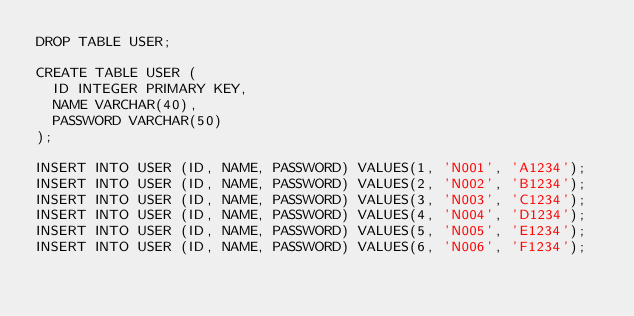Convert code to text. <code><loc_0><loc_0><loc_500><loc_500><_SQL_>DROP TABLE USER;

CREATE TABLE USER (
	ID INTEGER PRIMARY KEY,
	NAME VARCHAR(40),
	PASSWORD VARCHAR(50)
);

INSERT INTO USER (ID, NAME, PASSWORD) VALUES(1, 'N001', 'A1234');
INSERT INTO USER (ID, NAME, PASSWORD) VALUES(2, 'N002', 'B1234');
INSERT INTO USER (ID, NAME, PASSWORD) VALUES(3, 'N003', 'C1234');
INSERT INTO USER (ID, NAME, PASSWORD) VALUES(4, 'N004', 'D1234');
INSERT INTO USER (ID, NAME, PASSWORD) VALUES(5, 'N005', 'E1234');
INSERT INTO USER (ID, NAME, PASSWORD) VALUES(6, 'N006', 'F1234');
</code> 